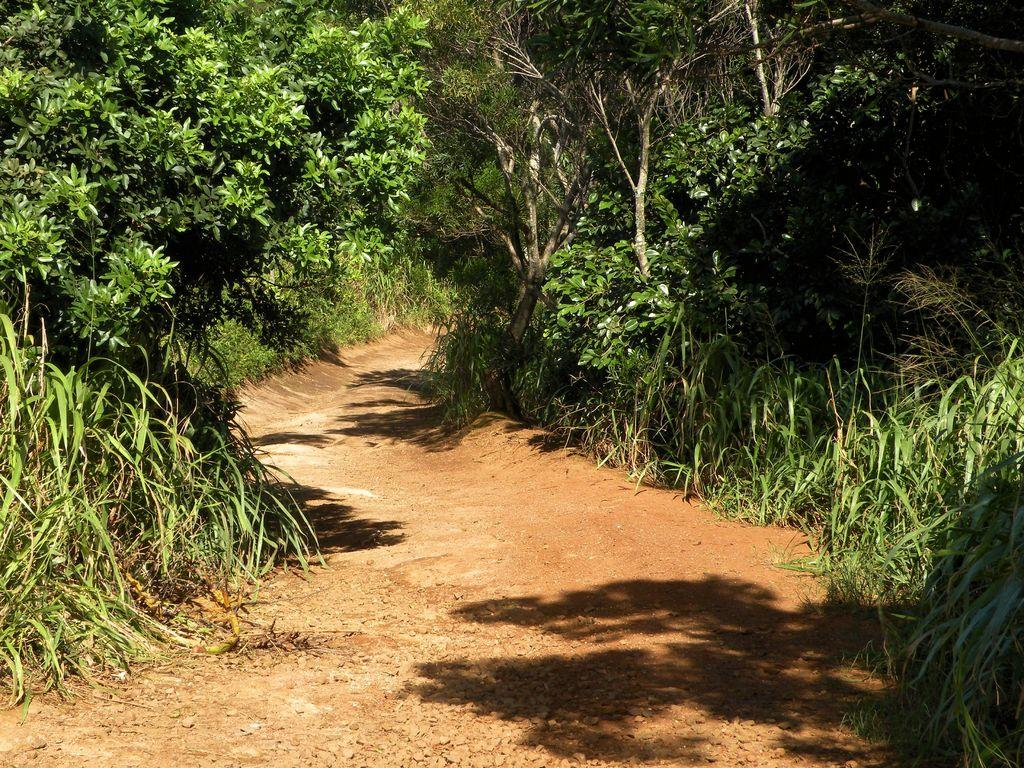What can be seen running through the image? There is a path in the image. What type of vegetation is present in the image? There are plants and trees in the image. What type of key is used to unlock the trees in the image? There are no keys or locks present in the image; the trees are not locked. 